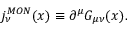Convert formula to latex. <formula><loc_0><loc_0><loc_500><loc_500>j _ { \nu } ^ { M O N } ( x ) \equiv \partial ^ { \mu } G _ { \mu \nu } ( x ) .</formula> 